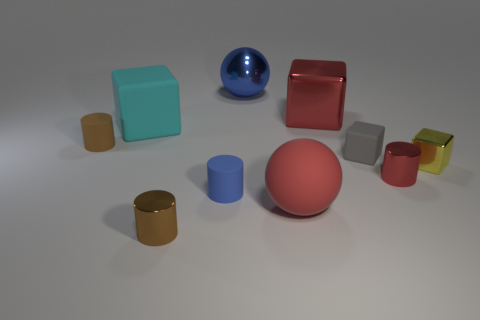Subtract 1 cylinders. How many cylinders are left? 3 Subtract all green cylinders. Subtract all gray cubes. How many cylinders are left? 4 Subtract all balls. How many objects are left? 8 Add 6 cyan cylinders. How many cyan cylinders exist? 6 Subtract 0 brown spheres. How many objects are left? 10 Subtract all large gray metal cylinders. Subtract all yellow metallic objects. How many objects are left? 9 Add 3 big blue objects. How many big blue objects are left? 4 